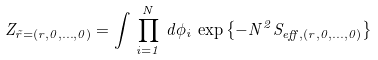<formula> <loc_0><loc_0><loc_500><loc_500>Z _ { \vec { r } = ( r , 0 , \dots , 0 ) } = \int \, \prod _ { i = 1 } ^ { N } \, d \phi _ { i } \, \exp \left \{ - N ^ { 2 } S _ { e f f , ( r , 0 , \dots , 0 ) } \right \}</formula> 